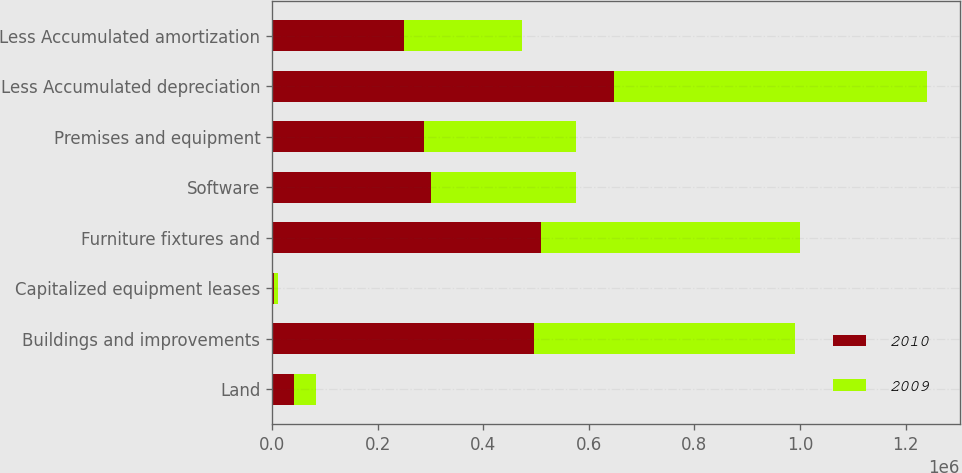Convert chart to OTSL. <chart><loc_0><loc_0><loc_500><loc_500><stacked_bar_chart><ecel><fcel>Land<fcel>Buildings and improvements<fcel>Capitalized equipment leases<fcel>Furniture fixtures and<fcel>Software<fcel>Premises and equipment<fcel>Less Accumulated depreciation<fcel>Less Accumulated amortization<nl><fcel>2010<fcel>41816<fcel>496352<fcel>3962<fcel>508599<fcel>300018<fcel>288158<fcel>647256<fcel>248877<nl><fcel>2009<fcel>41816<fcel>494511<fcel>7132<fcel>490594<fcel>276298<fcel>288158<fcel>593295<fcel>223871<nl></chart> 